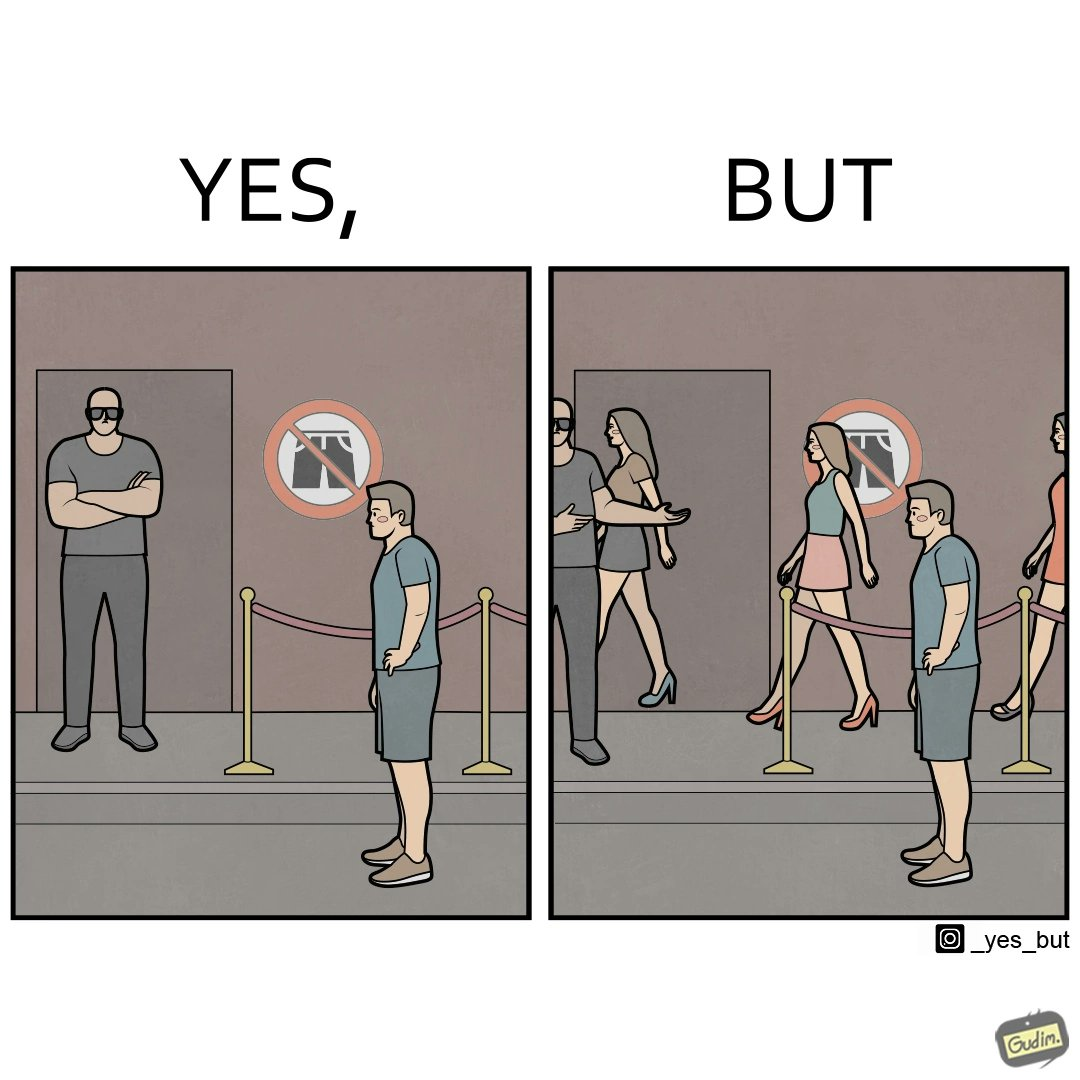Explain the humor or irony in this image. The image is ironic, because the same hotel which is not allowing the man to enter in shorts is allowing many girls to enter the hotel in shorts displaying the dual face of the hotel management 